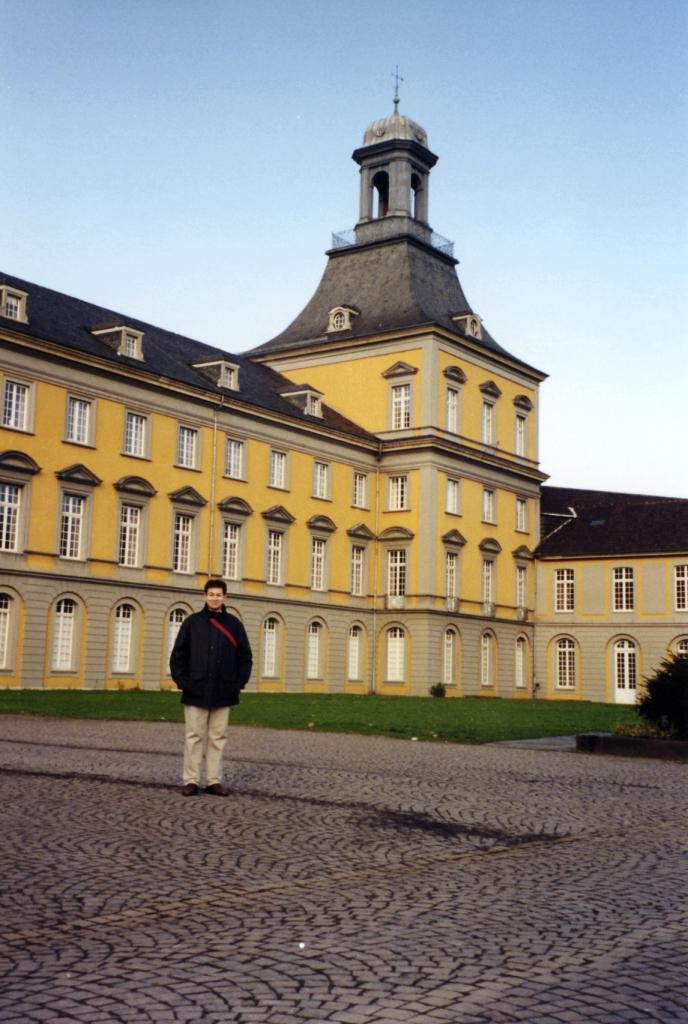How would you summarize this image in a sentence or two? In the center of the image, we can see a person on the road and in the background, there is a building and we can see a tree and there is ground. At the top, there is sky. 